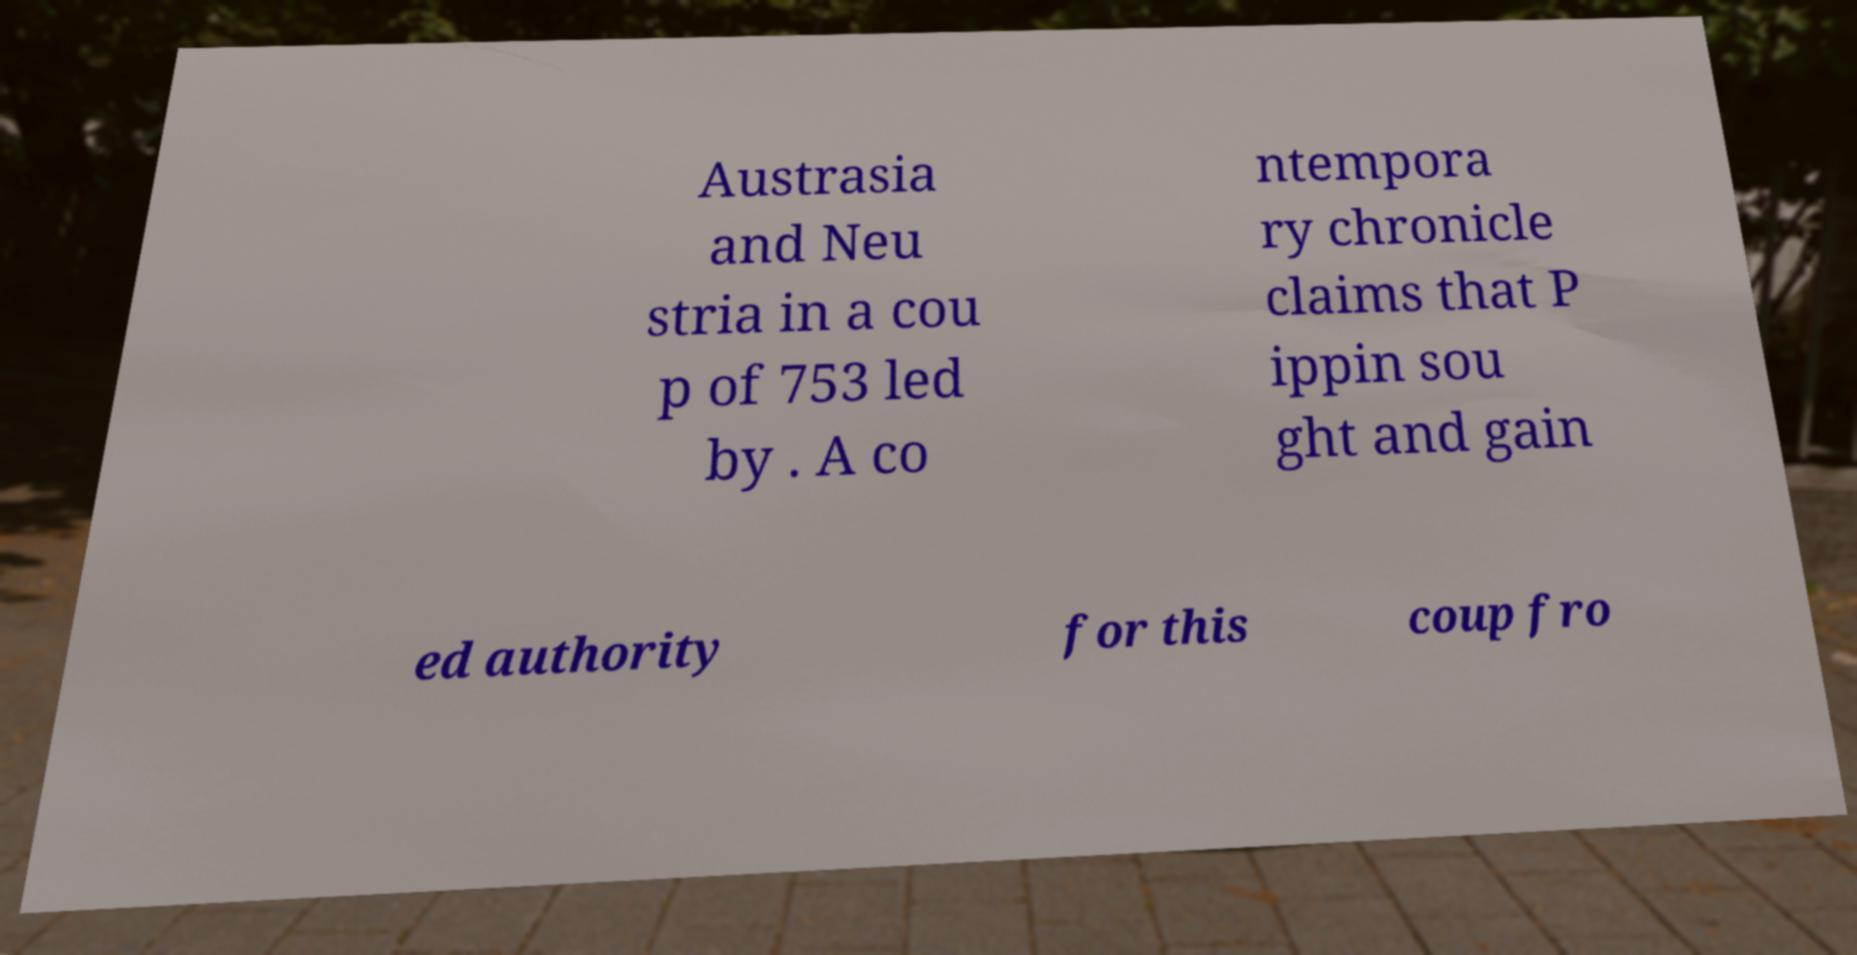Can you accurately transcribe the text from the provided image for me? Austrasia and Neu stria in a cou p of 753 led by . A co ntempora ry chronicle claims that P ippin sou ght and gain ed authority for this coup fro 